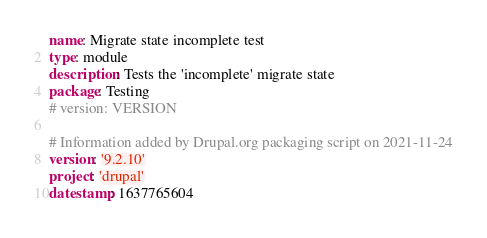Convert code to text. <code><loc_0><loc_0><loc_500><loc_500><_YAML_>name: Migrate state incomplete test
type: module
description: Tests the 'incomplete' migrate state
package: Testing
# version: VERSION

# Information added by Drupal.org packaging script on 2021-11-24
version: '9.2.10'
project: 'drupal'
datestamp: 1637765604
</code> 